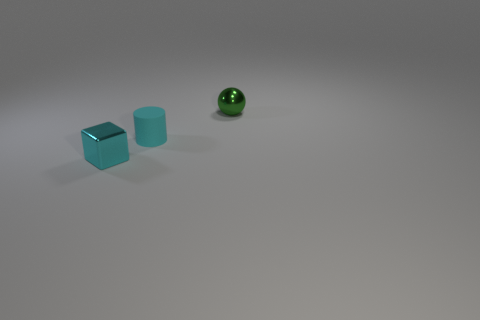There is a tiny green shiny thing; what shape is it?
Offer a very short reply. Sphere. Are there any metallic things in front of the green shiny thing?
Make the answer very short. Yes. Does the tiny green sphere have the same material as the small cyan thing that is behind the tiny metal cube?
Make the answer very short. No. What number of small green spheres are the same material as the small cylinder?
Your answer should be very brief. 0. How many objects are either tiny things that are in front of the small green object or metal balls?
Offer a terse response. 3. What material is the small cyan object behind the shiny object that is on the left side of the tiny green ball?
Provide a short and direct response. Rubber. Is there a small thing that has the same color as the tiny matte cylinder?
Your answer should be very brief. Yes. What number of things are shiny things right of the small metallic cube or things that are to the left of the tiny green object?
Your answer should be compact. 3. Is the color of the small block the same as the small ball?
Your answer should be compact. No. There is a tiny cube that is the same color as the tiny rubber thing; what is it made of?
Your answer should be compact. Metal. 